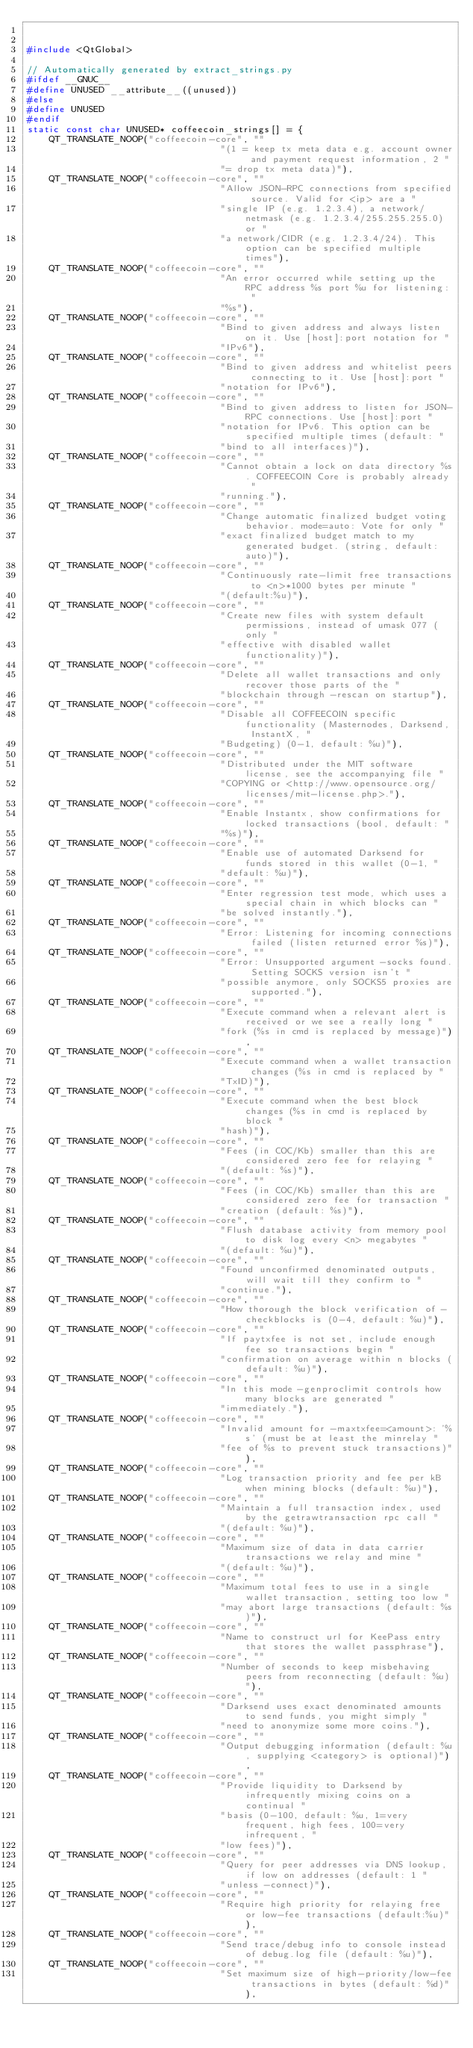<code> <loc_0><loc_0><loc_500><loc_500><_C++_>

#include <QtGlobal>

// Automatically generated by extract_strings.py
#ifdef __GNUC__
#define UNUSED __attribute__((unused))
#else
#define UNUSED
#endif
static const char UNUSED* coffeecoin_strings[] = {
    QT_TRANSLATE_NOOP("coffeecoin-core", ""
                                   "(1 = keep tx meta data e.g. account owner and payment request information, 2 "
                                   "= drop tx meta data)"),
    QT_TRANSLATE_NOOP("coffeecoin-core", ""
                                   "Allow JSON-RPC connections from specified source. Valid for <ip> are a "
                                   "single IP (e.g. 1.2.3.4), a network/netmask (e.g. 1.2.3.4/255.255.255.0) or "
                                   "a network/CIDR (e.g. 1.2.3.4/24). This option can be specified multiple times"),
    QT_TRANSLATE_NOOP("coffeecoin-core", ""
                                   "An error occurred while setting up the RPC address %s port %u for listening: "
                                   "%s"),
    QT_TRANSLATE_NOOP("coffeecoin-core", ""
                                   "Bind to given address and always listen on it. Use [host]:port notation for "
                                   "IPv6"),
    QT_TRANSLATE_NOOP("coffeecoin-core", ""
                                   "Bind to given address and whitelist peers connecting to it. Use [host]:port "
                                   "notation for IPv6"),
    QT_TRANSLATE_NOOP("coffeecoin-core", ""
                                   "Bind to given address to listen for JSON-RPC connections. Use [host]:port "
                                   "notation for IPv6. This option can be specified multiple times (default: "
                                   "bind to all interfaces)"),
    QT_TRANSLATE_NOOP("coffeecoin-core", ""
                                   "Cannot obtain a lock on data directory %s. COFFEECOIN Core is probably already "
                                   "running."),
    QT_TRANSLATE_NOOP("coffeecoin-core", ""
                                   "Change automatic finalized budget voting behavior. mode=auto: Vote for only "
                                   "exact finalized budget match to my generated budget. (string, default: auto)"),
    QT_TRANSLATE_NOOP("coffeecoin-core", ""
                                   "Continuously rate-limit free transactions to <n>*1000 bytes per minute "
                                   "(default:%u)"),
    QT_TRANSLATE_NOOP("coffeecoin-core", ""
                                   "Create new files with system default permissions, instead of umask 077 (only "
                                   "effective with disabled wallet functionality)"),
    QT_TRANSLATE_NOOP("coffeecoin-core", ""
                                   "Delete all wallet transactions and only recover those parts of the "
                                   "blockchain through -rescan on startup"),
    QT_TRANSLATE_NOOP("coffeecoin-core", ""
                                   "Disable all COFFEECOIN specific functionality (Masternodes, Darksend, InstantX, "
                                   "Budgeting) (0-1, default: %u)"),
    QT_TRANSLATE_NOOP("coffeecoin-core", ""
                                   "Distributed under the MIT software license, see the accompanying file "
                                   "COPYING or <http://www.opensource.org/licenses/mit-license.php>."),
    QT_TRANSLATE_NOOP("coffeecoin-core", ""
                                   "Enable Instantx, show confirmations for locked transactions (bool, default: "
                                   "%s)"),
    QT_TRANSLATE_NOOP("coffeecoin-core", ""
                                   "Enable use of automated Darksend for funds stored in this wallet (0-1, "
                                   "default: %u)"),
    QT_TRANSLATE_NOOP("coffeecoin-core", ""
                                   "Enter regression test mode, which uses a special chain in which blocks can "
                                   "be solved instantly."),
    QT_TRANSLATE_NOOP("coffeecoin-core", ""
                                   "Error: Listening for incoming connections failed (listen returned error %s)"),
    QT_TRANSLATE_NOOP("coffeecoin-core", ""
                                   "Error: Unsupported argument -socks found. Setting SOCKS version isn't "
                                   "possible anymore, only SOCKS5 proxies are supported."),
    QT_TRANSLATE_NOOP("coffeecoin-core", ""
                                   "Execute command when a relevant alert is received or we see a really long "
                                   "fork (%s in cmd is replaced by message)"),
    QT_TRANSLATE_NOOP("coffeecoin-core", ""
                                   "Execute command when a wallet transaction changes (%s in cmd is replaced by "
                                   "TxID)"),
    QT_TRANSLATE_NOOP("coffeecoin-core", ""
                                   "Execute command when the best block changes (%s in cmd is replaced by block "
                                   "hash)"),
    QT_TRANSLATE_NOOP("coffeecoin-core", ""
                                   "Fees (in COC/Kb) smaller than this are considered zero fee for relaying "
                                   "(default: %s)"),
    QT_TRANSLATE_NOOP("coffeecoin-core", ""
                                   "Fees (in COC/Kb) smaller than this are considered zero fee for transaction "
                                   "creation (default: %s)"),
    QT_TRANSLATE_NOOP("coffeecoin-core", ""
                                   "Flush database activity from memory pool to disk log every <n> megabytes "
                                   "(default: %u)"),
    QT_TRANSLATE_NOOP("coffeecoin-core", ""
                                   "Found unconfirmed denominated outputs, will wait till they confirm to "
                                   "continue."),
    QT_TRANSLATE_NOOP("coffeecoin-core", ""
                                   "How thorough the block verification of -checkblocks is (0-4, default: %u)"),
    QT_TRANSLATE_NOOP("coffeecoin-core", ""
                                   "If paytxfee is not set, include enough fee so transactions begin "
                                   "confirmation on average within n blocks (default: %u)"),
    QT_TRANSLATE_NOOP("coffeecoin-core", ""
                                   "In this mode -genproclimit controls how many blocks are generated "
                                   "immediately."),
    QT_TRANSLATE_NOOP("coffeecoin-core", ""
                                   "Invalid amount for -maxtxfee=<amount>: '%s' (must be at least the minrelay "
                                   "fee of %s to prevent stuck transactions)"),
    QT_TRANSLATE_NOOP("coffeecoin-core", ""
                                   "Log transaction priority and fee per kB when mining blocks (default: %u)"),
    QT_TRANSLATE_NOOP("coffeecoin-core", ""
                                   "Maintain a full transaction index, used by the getrawtransaction rpc call "
                                   "(default: %u)"),
    QT_TRANSLATE_NOOP("coffeecoin-core", ""
                                   "Maximum size of data in data carrier transactions we relay and mine "
                                   "(default: %u)"),
    QT_TRANSLATE_NOOP("coffeecoin-core", ""
                                   "Maximum total fees to use in a single wallet transaction, setting too low "
                                   "may abort large transactions (default: %s)"),
    QT_TRANSLATE_NOOP("coffeecoin-core", ""
                                   "Name to construct url for KeePass entry that stores the wallet passphrase"),
    QT_TRANSLATE_NOOP("coffeecoin-core", ""
                                   "Number of seconds to keep misbehaving peers from reconnecting (default: %u)"),
    QT_TRANSLATE_NOOP("coffeecoin-core", ""
                                   "Darksend uses exact denominated amounts to send funds, you might simply "
                                   "need to anonymize some more coins."),
    QT_TRANSLATE_NOOP("coffeecoin-core", ""
                                   "Output debugging information (default: %u, supplying <category> is optional)"),
    QT_TRANSLATE_NOOP("coffeecoin-core", ""
                                   "Provide liquidity to Darksend by infrequently mixing coins on a continual "
                                   "basis (0-100, default: %u, 1=very frequent, high fees, 100=very infrequent, "
                                   "low fees)"),
    QT_TRANSLATE_NOOP("coffeecoin-core", ""
                                   "Query for peer addresses via DNS lookup, if low on addresses (default: 1 "
                                   "unless -connect)"),
    QT_TRANSLATE_NOOP("coffeecoin-core", ""
                                   "Require high priority for relaying free or low-fee transactions (default:%u)"),
    QT_TRANSLATE_NOOP("coffeecoin-core", ""
                                   "Send trace/debug info to console instead of debug.log file (default: %u)"),
    QT_TRANSLATE_NOOP("coffeecoin-core", ""
                                   "Set maximum size of high-priority/low-fee transactions in bytes (default: %d)"),</code> 